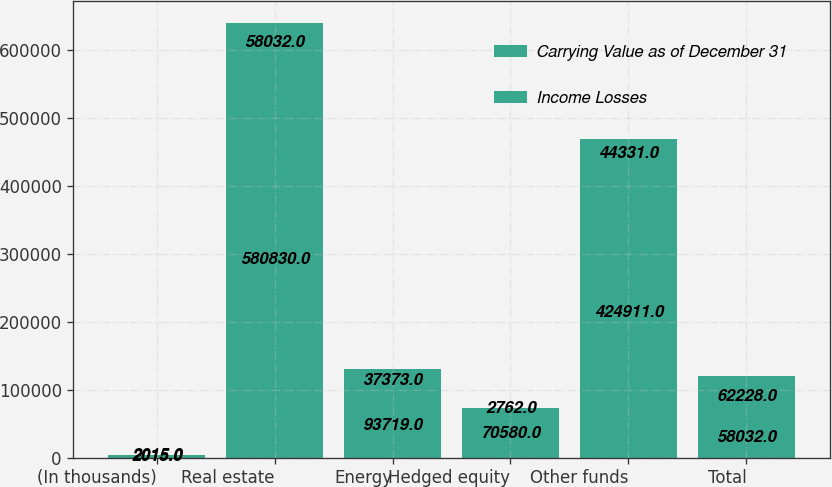Convert chart. <chart><loc_0><loc_0><loc_500><loc_500><stacked_bar_chart><ecel><fcel>(In thousands)<fcel>Real estate<fcel>Energy<fcel>Hedged equity<fcel>Other funds<fcel>Total<nl><fcel>Carrying Value as of December 31<fcel>2015<fcel>580830<fcel>93719<fcel>70580<fcel>424911<fcel>58032<nl><fcel>Income Losses<fcel>2015<fcel>58032<fcel>37373<fcel>2762<fcel>44331<fcel>62228<nl></chart> 